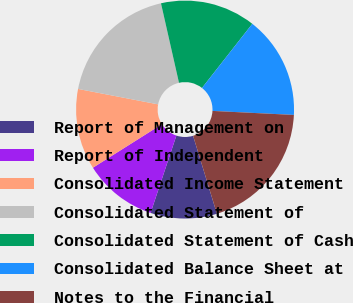Convert chart. <chart><loc_0><loc_0><loc_500><loc_500><pie_chart><fcel>Report of Management on<fcel>Report of Independent<fcel>Consolidated Income Statement<fcel>Consolidated Statement of<fcel>Consolidated Statement of Cash<fcel>Consolidated Balance Sheet at<fcel>Notes to the Financial<nl><fcel>9.84%<fcel>10.92%<fcel>11.99%<fcel>18.42%<fcel>14.13%<fcel>15.2%<fcel>19.49%<nl></chart> 